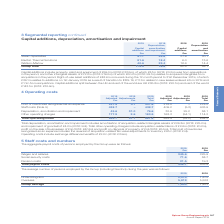According to Spirax Sarco Engineering Plc's financial document, How were the capital additions in 2019 split? Capital additions split between the UK and rest of the world are UK £36.8m (2018: £20.1m) and rest of the world £143.1m. The document states: "entered into in 2019 and £1.1m from acquisitions. Capital additions split between the UK and rest of the world are UK £36.8m (2018: £20.1m) and rest o..." Also, What does capital additions include? property, plant and equipment of £59.0m (2018: £33.5m), of which £8.1m (2018: £0.2m) was from acquisitions in the period, and other intangible assets of £72.0m (2018: £19.0m) of which £60.2m (2018: £9.1m) relates to acquired intangibles from acquisitions in the period. The document states: "Capital additions include property, plant and equipment of £59.0m (2018: £33.5m), of which £8.1m (2018: £0.2m) was from acquisitions in the period, an..." Also, What are the businesses considered in the table? The document contains multiple relevant values: Steam Specialties, Electric Thermal Solutions, Watson-Marlow. From the document: "2018 Depreciation and amortisation £m Steam Specialties 57.7 35.8 27.9 30.1 Electric Thermal Solutions 81.6 18.4 6.0 13.6 Watson-Marlow 40.6 22.4 18.6..." Additionally, In which year was the amount of capital additions for Steam Specialties larger? According to the financial document, 2019. The relevant text states: "Annual Report 2019..." Also, can you calculate: What was the amount of capital additions for the UK as a percentage of the group total in 2019? To answer this question, I need to perform calculations using the financial data. The calculation is: 36.8/(36.8+143.1), which equals 20.46 (percentage). This is based on the information: "e UK £36.8m (2018: £20.1m) and rest of the world £143.1m (2018: £32.4m). plit between the UK and rest of the world are UK £36.8m (2018: £20.1m) and rest of the world £143.1m (2018: £32.4m)...." The key data points involved are: 143.1, 36.8. Also, can you calculate: What was the percentage change in capital additions in 2019 from 2018 for Steam Specialties? To answer this question, I need to perform calculations using the financial data. The calculation is: (57.7-27.9)/27.9, which equals 106.81 (percentage). This is based on the information: "epreciation and amortisation £m Steam Specialties 57.7 35.8 27.9 30.1 Electric Thermal Solutions 81.6 18.4 6.0 13.6 Watson-Marlow 40.6 22.4 18.6 14.4 Grou n and amortisation £m Steam Specialties 57.7 ..." The key data points involved are: 27.9, 57.7. 